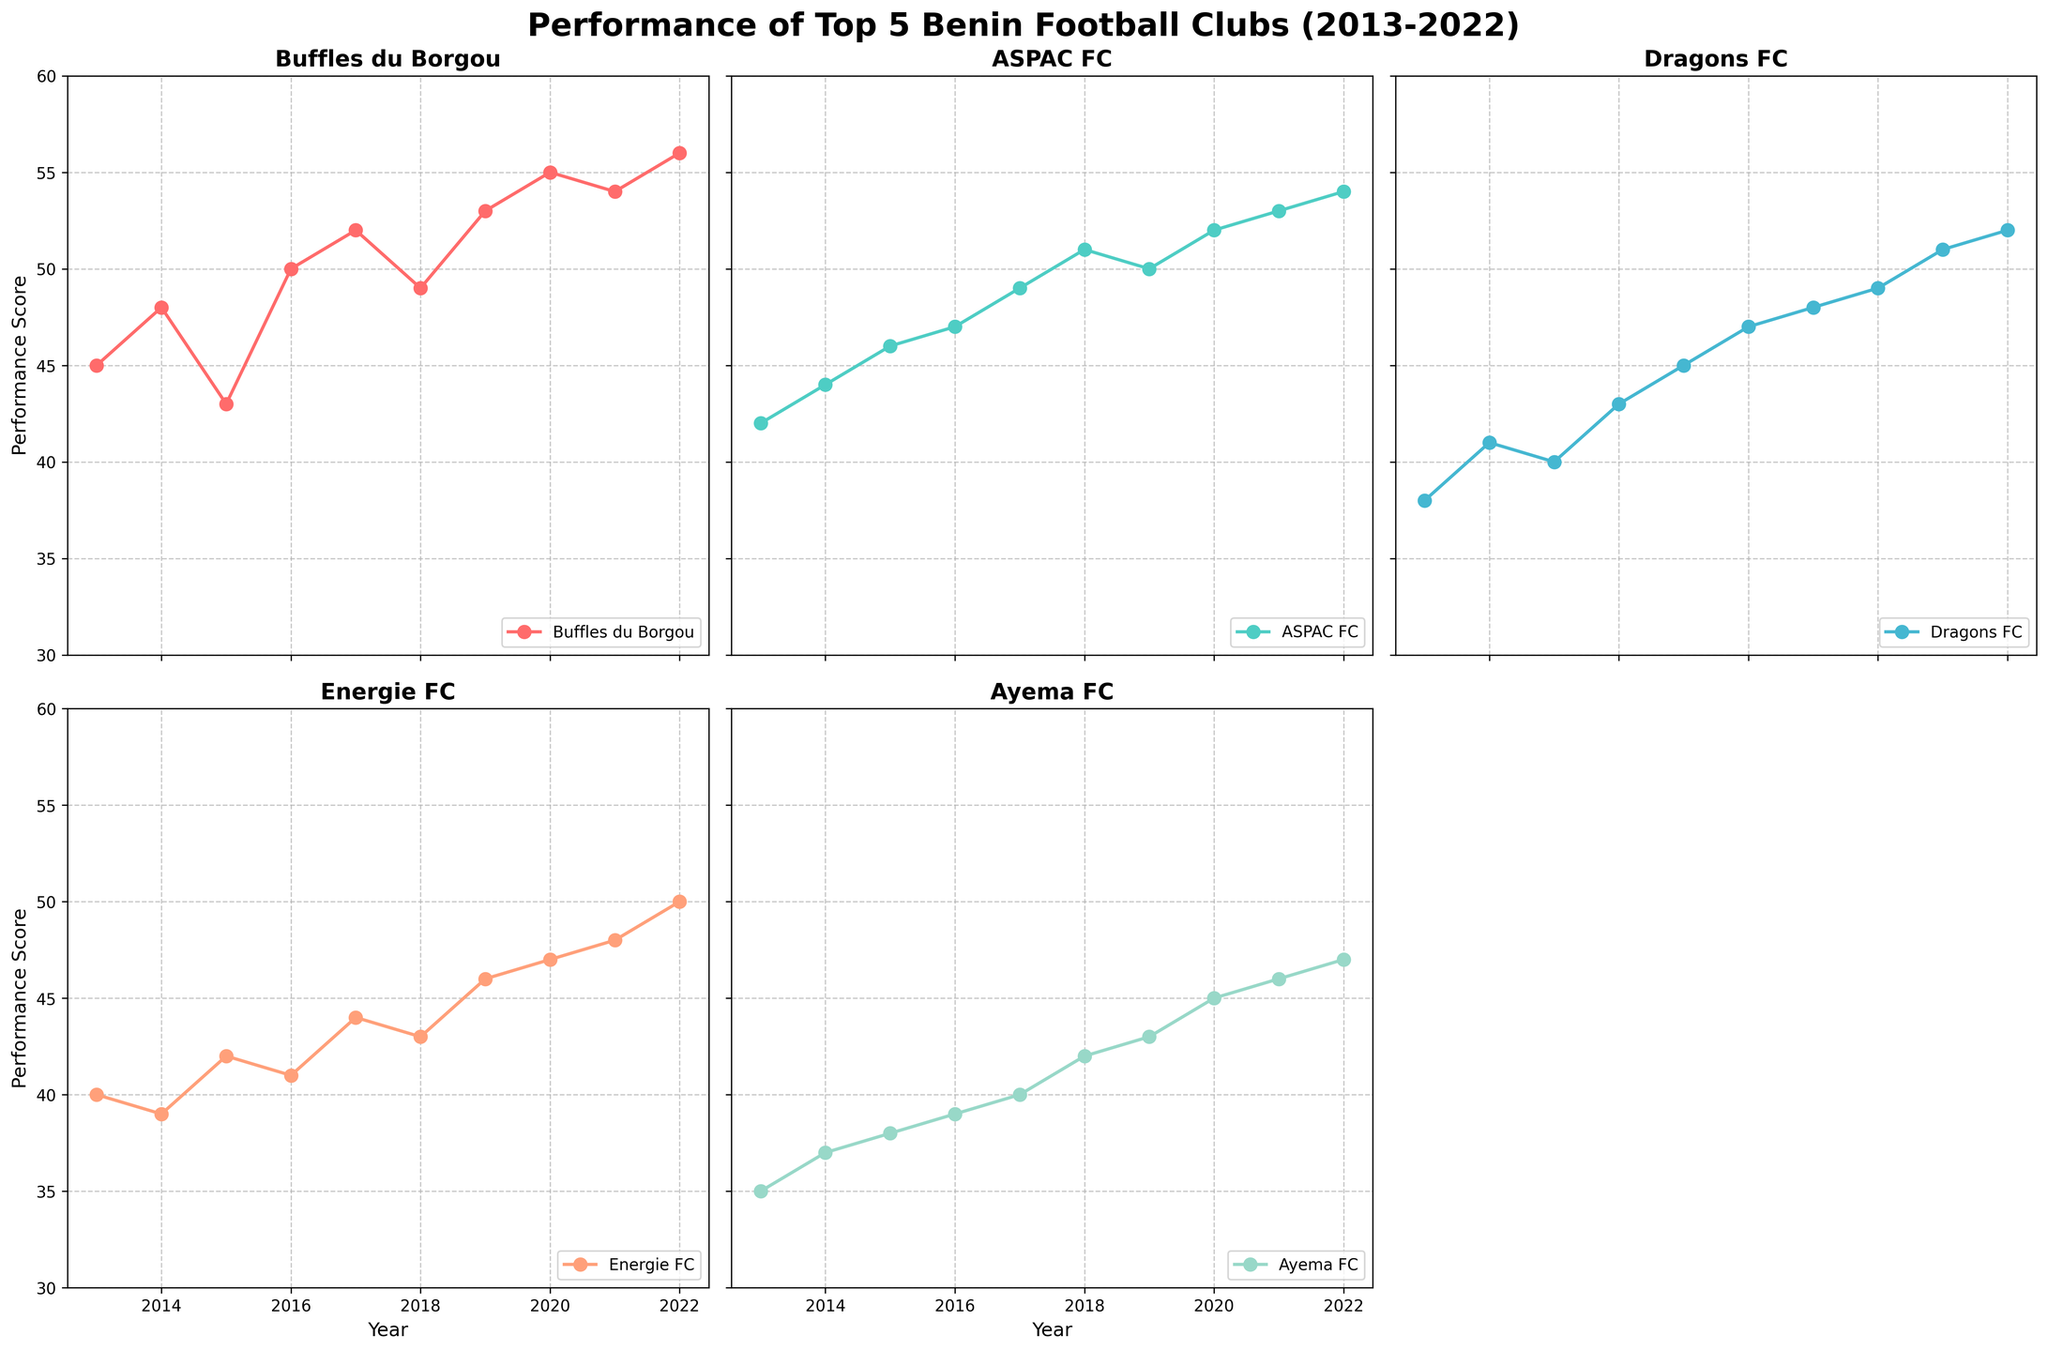Which team had the highest performance score in 2022? Check the end of the line for each team in the subplots and find the highest value for the year 2022. Buffles du Borgou scored 56.
Answer: Buffles du Borgou Which club had the lowest performance score in 2016? Refer to each subplot and compare the performance scores of each club in 2016. Ayema FC had the lowest score with 39.
Answer: Ayema FC How many clubs had performance scores increasing every year from 2013 to 2022? Examine the trend lines for each club. Buffles du Borgou, ASPAC FC, and Dragons FC show a consistent increasing trend.
Answer: 3 What is the average performance score of Dragons FC from 2013 to 2022? Sum the values of Dragons FC from 2013 to 2022 and divide by the number of years (10). (38 + 41 + 40 + 43 + 45 + 47 + 48 + 49 + 51 + 52) = 404 / 10 = 40.4
Answer: 40.4 Between 2019 and 2020, which club showed the largest increase in performance score? Calculate the differences in performance scores for each club between 2019 and 2020. Buffles du Borgou increased by 2 points (53 to 55), which is the largest.
Answer: Buffles du Borgou What was the performance score of Energie FC in 2017? Refer to the subplot of Energie FC and look for the performance score in 2017. The score is 44.
Answer: 44 In which year did Ayema FC start to outperform Energie FC? Compare the performance scores of Ayema FC and Energie FC year-by-year. Ayema FC started outperforming Energie FC in 2019.
Answer: 2019 What was the performance trend for ASPAC FC from 2013 to 2022? Look at the trendline in the ASPAC FC subplot. It consistently increased from 42 in 2013 to 54 in 2022.
Answer: Increasing Which club had the most consistent performance score from 2013 to 2022? Look at the trendlines to determine the club with the least fluctuation. ASPAC FC had a steady increase without significant fluctuations.
Answer: ASPAC FC 